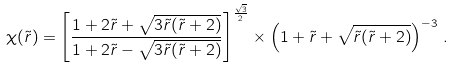Convert formula to latex. <formula><loc_0><loc_0><loc_500><loc_500>\chi ( \tilde { r } ) = \left [ \frac { 1 + 2 \tilde { r } + \sqrt { 3 \tilde { r } ( \tilde { r } + 2 ) } } { 1 + 2 \tilde { r } - \sqrt { 3 \tilde { r } ( \tilde { r } + 2 ) } } \right ] ^ { \frac { \sqrt { 3 } } { 2 } } \times \left ( 1 + \tilde { r } + \sqrt { \tilde { r } ( \tilde { r } + 2 ) } \right ) ^ { - 3 } \, .</formula> 